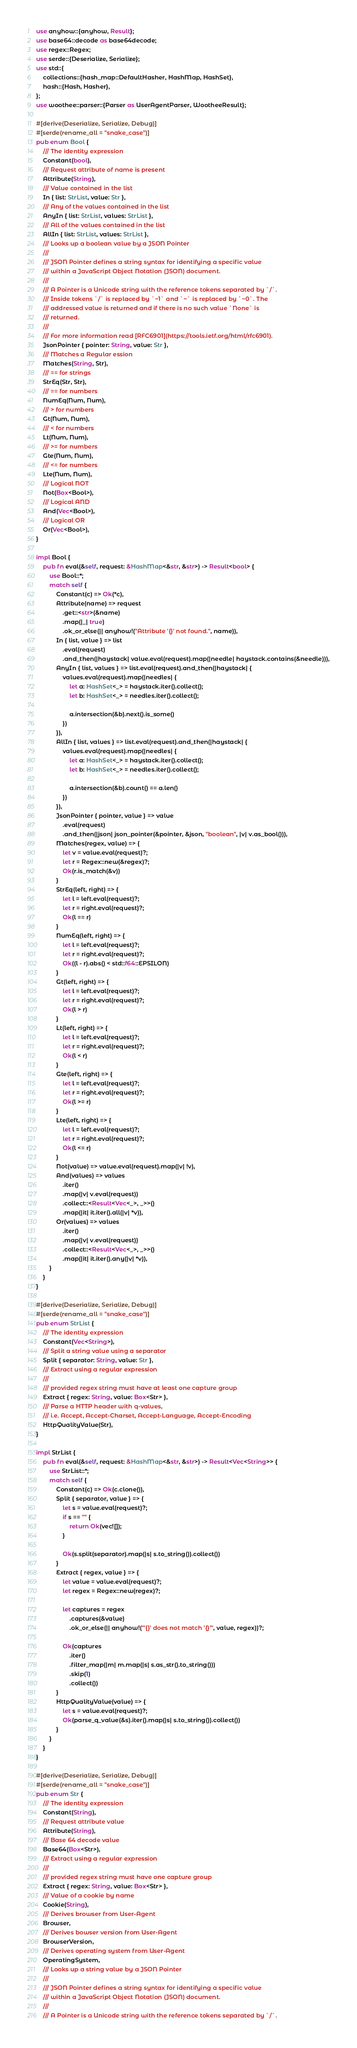Convert code to text. <code><loc_0><loc_0><loc_500><loc_500><_Rust_>use anyhow::{anyhow, Result};
use base64::decode as base64decode;
use regex::Regex;
use serde::{Deserialize, Serialize};
use std::{
    collections::{hash_map::DefaultHasher, HashMap, HashSet},
    hash::{Hash, Hasher},
};
use woothee::parser::{Parser as UserAgentParser, WootheeResult};

#[derive(Deserialize, Serialize, Debug)]
#[serde(rename_all = "snake_case")]
pub enum Bool {
    /// The identity expression
    Constant(bool),
    /// Request attribute of name is present
    Attribute(String),
    /// Value contained in the list
    In { list: StrList, value: Str },
    /// Any of the values contained in the list
    AnyIn { list: StrList, values: StrList },
    /// All of the values contained in the list
    AllIn { list: StrList, values: StrList },
    /// Looks up a boolean value by a JSON Pointer
    ///
    /// JSON Pointer defines a string syntax for identifying a specific value
    /// within a JavaScript Object Notation (JSON) document.
    ///
    /// A Pointer is a Unicode string with the reference tokens separated by `/`.
    /// Inside tokens `/` is replaced by `~1` and `~` is replaced by `~0`. The
    /// addressed value is returned and if there is no such value `None` is
    /// returned.
    ///
    /// For more information read [RFC6901](https://tools.ietf.org/html/rfc6901).
    JsonPointer { pointer: String, value: Str },
    /// Matches a Regular ession
    Matches(String, Str),
    /// == for strings
    StrEq(Str, Str),
    /// == for numbers
    NumEq(Num, Num),
    /// > for numbers
    Gt(Num, Num),
    /// < for numbers
    Lt(Num, Num),
    /// >= for numbers
    Gte(Num, Num),
    /// <= for numbers
    Lte(Num, Num),
    /// Logical NOT
    Not(Box<Bool>),
    /// Logical AND
    And(Vec<Bool>),
    /// Logical OR
    Or(Vec<Bool>),
}

impl Bool {
    pub fn eval(&self, request: &HashMap<&str, &str>) -> Result<bool> {
        use Bool::*;
        match self {
            Constant(c) => Ok(*c),
            Attribute(name) => request
                .get::<str>(&name)
                .map(|_| true)
                .ok_or_else(|| anyhow!("Attribute '{}' not found.", name)),
            In { list, value } => list
                .eval(request)
                .and_then(|haystack| value.eval(request).map(|needle| haystack.contains(&needle))),
            AnyIn { list, values } => list.eval(request).and_then(|haystack| {
                values.eval(request).map(|needles| {
                    let a: HashSet<_> = haystack.iter().collect();
                    let b: HashSet<_> = needles.iter().collect();

                    a.intersection(&b).next().is_some()
                })
            }),
            AllIn { list, values } => list.eval(request).and_then(|haystack| {
                values.eval(request).map(|needles| {
                    let a: HashSet<_> = haystack.iter().collect();
                    let b: HashSet<_> = needles.iter().collect();

                    a.intersection(&b).count() == a.len()
                })
            }),
            JsonPointer { pointer, value } => value
                .eval(request)
                .and_then(|json| json_pointer(&pointer, &json, "boolean", |v| v.as_bool())),
            Matches(regex, value) => {
                let v = value.eval(request)?;
                let r = Regex::new(&regex)?;
                Ok(r.is_match(&v))
            }
            StrEq(left, right) => {
                let l = left.eval(request)?;
                let r = right.eval(request)?;
                Ok(l == r)
            }
            NumEq(left, right) => {
                let l = left.eval(request)?;
                let r = right.eval(request)?;
                Ok((l - r).abs() < std::f64::EPSILON)
            }
            Gt(left, right) => {
                let l = left.eval(request)?;
                let r = right.eval(request)?;
                Ok(l > r)
            }
            Lt(left, right) => {
                let l = left.eval(request)?;
                let r = right.eval(request)?;
                Ok(l < r)
            }
            Gte(left, right) => {
                let l = left.eval(request)?;
                let r = right.eval(request)?;
                Ok(l >= r)
            }
            Lte(left, right) => {
                let l = left.eval(request)?;
                let r = right.eval(request)?;
                Ok(l <= r)
            }
            Not(value) => value.eval(request).map(|v| !v),
            And(values) => values
                .iter()
                .map(|v| v.eval(request))
                .collect::<Result<Vec<_>, _>>()
                .map(|it| it.iter().all(|v| *v)),
            Or(values) => values
                .iter()
                .map(|v| v.eval(request))
                .collect::<Result<Vec<_>, _>>()
                .map(|it| it.iter().any(|v| *v)),
        }
    }
}

#[derive(Deserialize, Serialize, Debug)]
#[serde(rename_all = "snake_case")]
pub enum StrList {
    /// The identity expression
    Constant(Vec<String>),
    /// Split a string value using a separator
    Split { separator: String, value: Str },
    /// Extract using a regular expression
    ///
    /// provided regex string must have at least one capture group
    Extract { regex: String, value: Box<Str> },
    /// Parse a HTTP header with q-values,
    /// i.e. Accept, Accept-Charset, Accept-Language, Accept-Encoding
    HttpQualityValue(Str),
}

impl StrList {
    pub fn eval(&self, request: &HashMap<&str, &str>) -> Result<Vec<String>> {
        use StrList::*;
        match self {
            Constant(c) => Ok(c.clone()),
            Split { separator, value } => {
                let s = value.eval(request)?;
                if s == "" {
                    return Ok(vec![]);
                }

                Ok(s.split(separator).map(|s| s.to_string()).collect())
            }
            Extract { regex, value } => {
                let value = value.eval(request)?;
                let regex = Regex::new(regex)?;

                let captures = regex
                    .captures(&value)
                    .ok_or_else(|| anyhow!("'{}' does not match '{}'", value, regex))?;

                Ok(captures
                    .iter()
                    .filter_map(|m| m.map(|s| s.as_str().to_string()))
                    .skip(1)
                    .collect())
            }
            HttpQualityValue(value) => {
                let s = value.eval(request)?;
                Ok(parse_q_value(&s).iter().map(|s| s.to_string()).collect())
            }
        }
    }
}

#[derive(Deserialize, Serialize, Debug)]
#[serde(rename_all = "snake_case")]
pub enum Str {
    /// The identity expression
    Constant(String),
    /// Request attribute value
    Attribute(String),
    /// Base 64 decode value
    Base64(Box<Str>),
    /// Extract using a regular expression
    ///
    /// provided regex string must have one capture group
    Extract { regex: String, value: Box<Str> },
    /// Value of a cookie by name
    Cookie(String),
    /// Derives browser from User-Agent
    Browser,
    /// Derives bowser version from User-Agent
    BrowserVersion,
    /// Derives operating system from User-Agent
    OperatingSystem,
    /// Looks up a string value by a JSON Pointer
    ///
    /// JSON Pointer defines a string syntax for identifying a specific value
    /// within a JavaScript Object Notation (JSON) document.
    ///
    /// A Pointer is a Unicode string with the reference tokens separated by `/`.</code> 